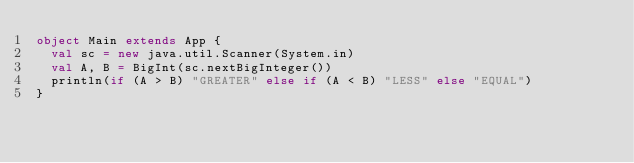Convert code to text. <code><loc_0><loc_0><loc_500><loc_500><_Scala_>object Main extends App {
  val sc = new java.util.Scanner(System.in)
  val A, B = BigInt(sc.nextBigInteger())
  println(if (A > B) "GREATER" else if (A < B) "LESS" else "EQUAL")
}
</code> 